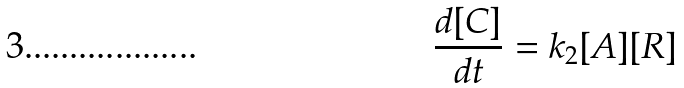Convert formula to latex. <formula><loc_0><loc_0><loc_500><loc_500>\frac { d [ C ] } { d t } = k _ { 2 } [ A ] [ R ]</formula> 